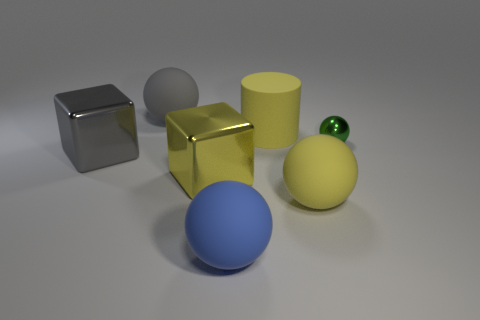The gray matte object has what size?
Provide a succinct answer. Large. How many other objects are the same color as the metal sphere?
Offer a very short reply. 0. Is the large yellow thing that is left of the blue rubber sphere made of the same material as the big sphere that is left of the big blue matte thing?
Make the answer very short. No. Is there anything else that has the same size as the green shiny sphere?
Keep it short and to the point. No. There is a yellow object that is left of the yellow ball and in front of the large yellow cylinder; what is its shape?
Your answer should be very brief. Cube. There is a ball that is left of the big yellow metallic thing that is on the left side of the large matte thing that is in front of the big yellow ball; what is it made of?
Your answer should be compact. Rubber. What size is the yellow rubber thing behind the green metallic sphere that is right of the large rubber cylinder behind the tiny ball?
Offer a terse response. Large. There is a small shiny thing; how many yellow matte things are behind it?
Keep it short and to the point. 1. Does the big block that is in front of the gray metallic block have the same color as the rubber cylinder?
Your answer should be compact. Yes. How many purple objects are small things or metallic objects?
Give a very brief answer. 0. 